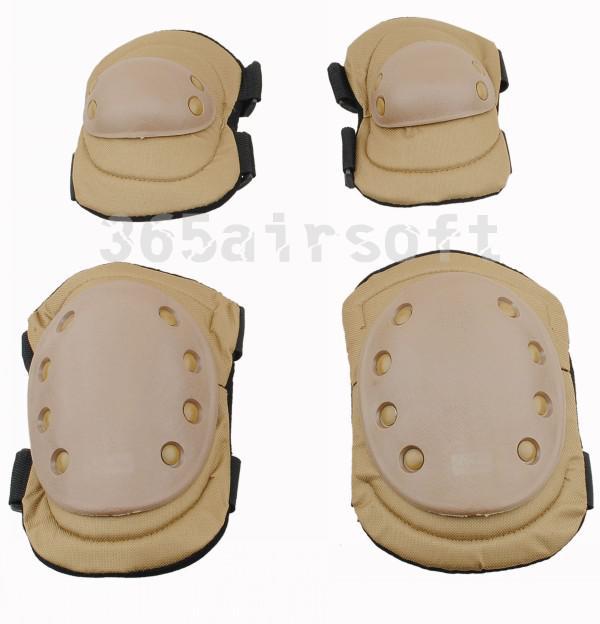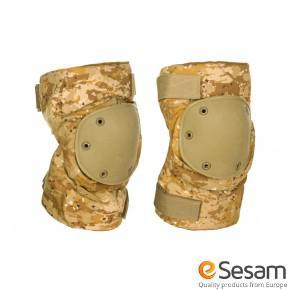The first image is the image on the left, the second image is the image on the right. For the images displayed, is the sentence "The kneepads in one image are camouflage and the other image has tan kneepads." factually correct? Answer yes or no. Yes. 